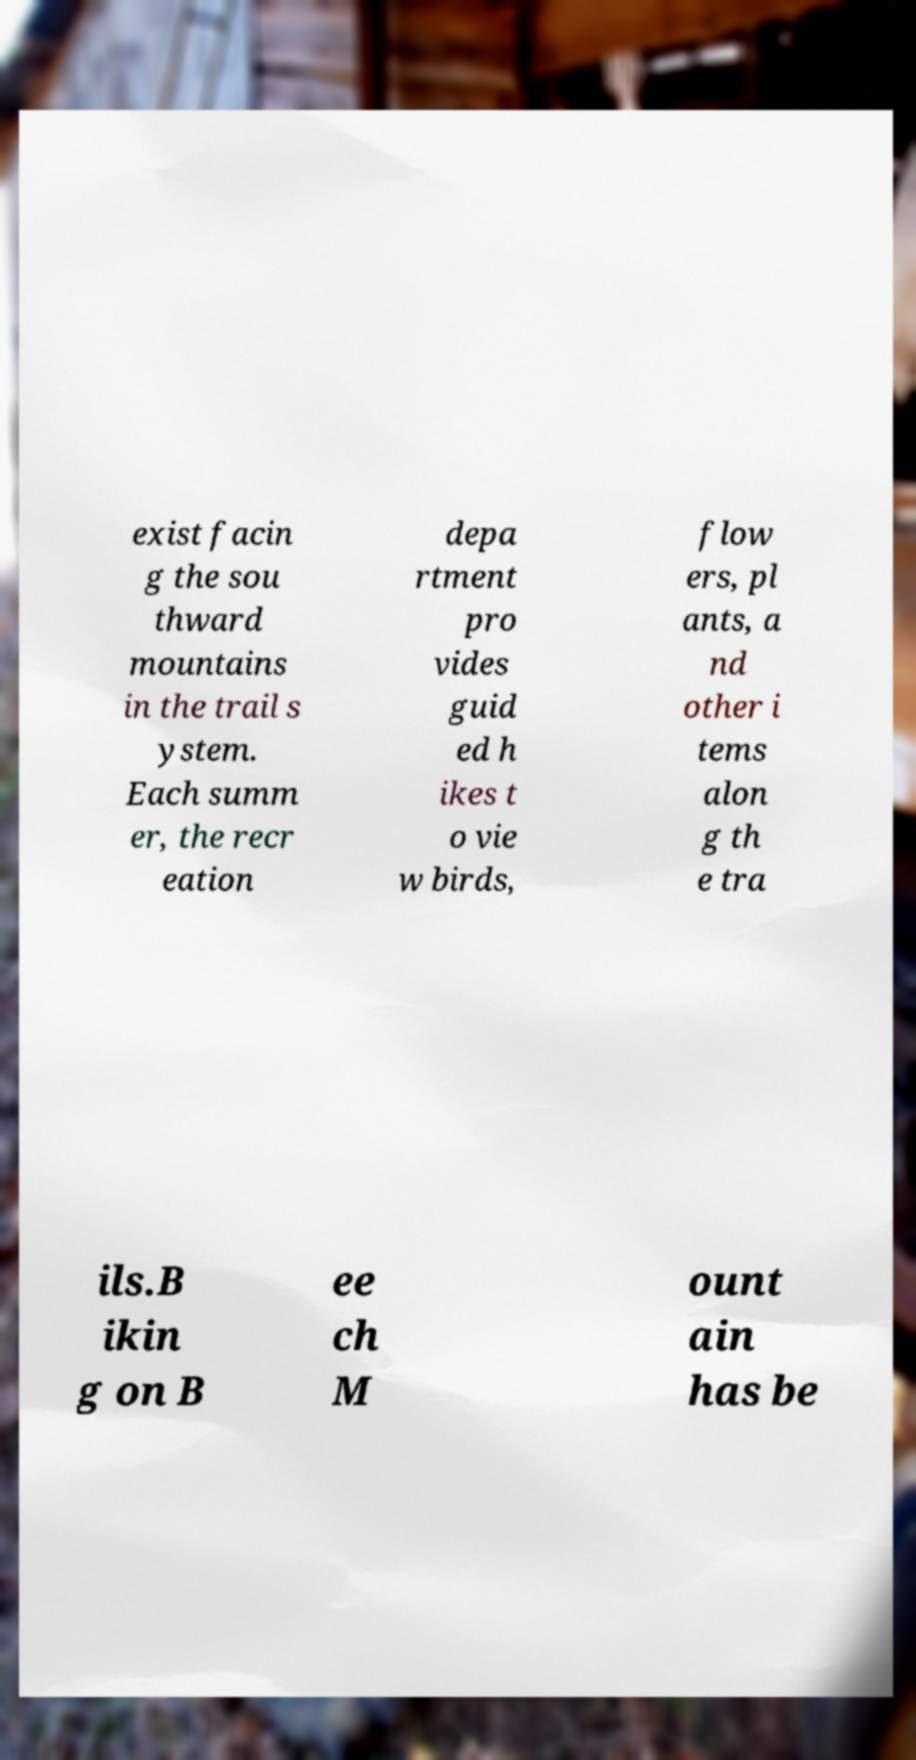Could you assist in decoding the text presented in this image and type it out clearly? exist facin g the sou thward mountains in the trail s ystem. Each summ er, the recr eation depa rtment pro vides guid ed h ikes t o vie w birds, flow ers, pl ants, a nd other i tems alon g th e tra ils.B ikin g on B ee ch M ount ain has be 